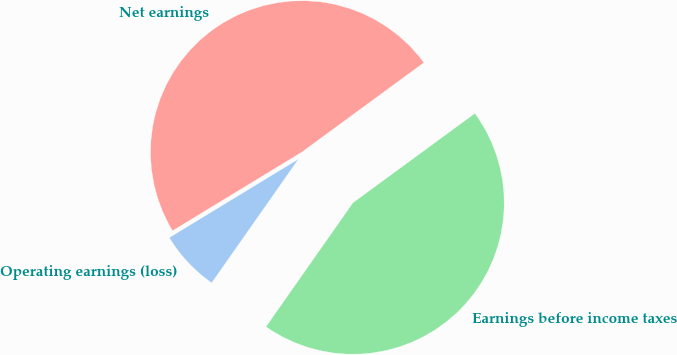Convert chart to OTSL. <chart><loc_0><loc_0><loc_500><loc_500><pie_chart><fcel>Operating earnings (loss)<fcel>Earnings before income taxes<fcel>Net earnings<nl><fcel>6.57%<fcel>44.8%<fcel>48.63%<nl></chart> 